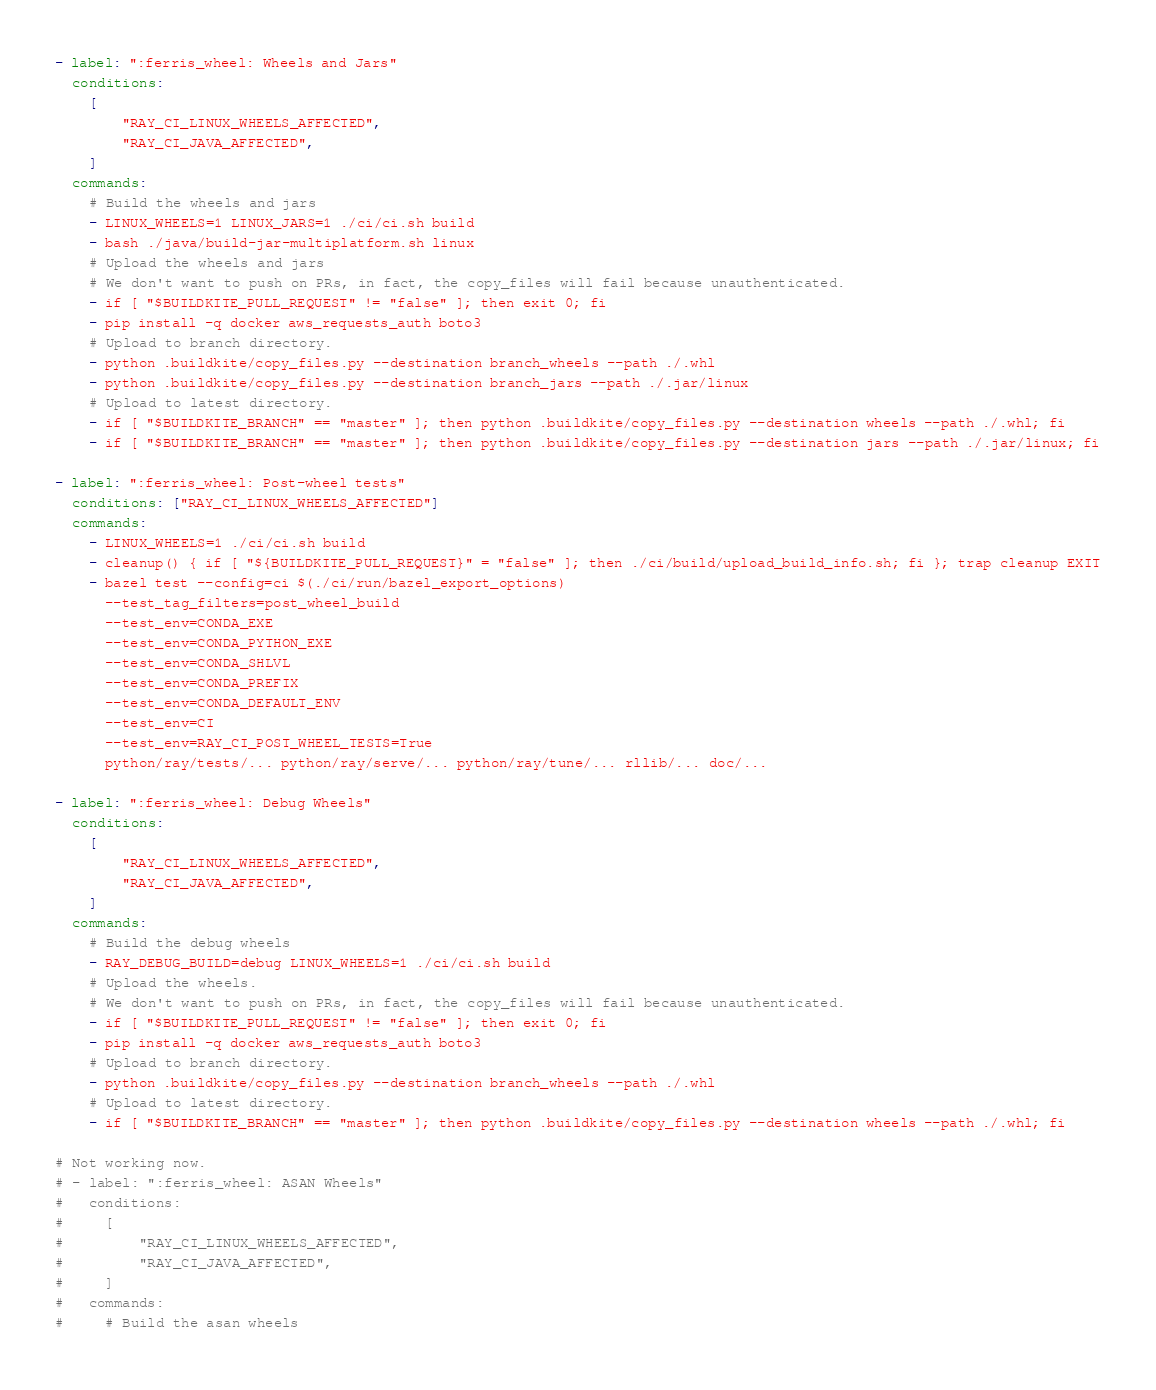<code> <loc_0><loc_0><loc_500><loc_500><_YAML_>- label: ":ferris_wheel: Wheels and Jars"
  conditions:
    [
        "RAY_CI_LINUX_WHEELS_AFFECTED",
        "RAY_CI_JAVA_AFFECTED",
    ]
  commands:
    # Build the wheels and jars
    - LINUX_WHEELS=1 LINUX_JARS=1 ./ci/ci.sh build
    - bash ./java/build-jar-multiplatform.sh linux
    # Upload the wheels and jars
    # We don't want to push on PRs, in fact, the copy_files will fail because unauthenticated.
    - if [ "$BUILDKITE_PULL_REQUEST" != "false" ]; then exit 0; fi
    - pip install -q docker aws_requests_auth boto3
    # Upload to branch directory.
    - python .buildkite/copy_files.py --destination branch_wheels --path ./.whl
    - python .buildkite/copy_files.py --destination branch_jars --path ./.jar/linux
    # Upload to latest directory.
    - if [ "$BUILDKITE_BRANCH" == "master" ]; then python .buildkite/copy_files.py --destination wheels --path ./.whl; fi
    - if [ "$BUILDKITE_BRANCH" == "master" ]; then python .buildkite/copy_files.py --destination jars --path ./.jar/linux; fi

- label: ":ferris_wheel: Post-wheel tests"
  conditions: ["RAY_CI_LINUX_WHEELS_AFFECTED"]
  commands:
    - LINUX_WHEELS=1 ./ci/ci.sh build
    - cleanup() { if [ "${BUILDKITE_PULL_REQUEST}" = "false" ]; then ./ci/build/upload_build_info.sh; fi }; trap cleanup EXIT
    - bazel test --config=ci $(./ci/run/bazel_export_options)
      --test_tag_filters=post_wheel_build
      --test_env=CONDA_EXE
      --test_env=CONDA_PYTHON_EXE
      --test_env=CONDA_SHLVL
      --test_env=CONDA_PREFIX
      --test_env=CONDA_DEFAULT_ENV
      --test_env=CI
      --test_env=RAY_CI_POST_WHEEL_TESTS=True
      python/ray/tests/... python/ray/serve/... python/ray/tune/... rllib/... doc/...

- label: ":ferris_wheel: Debug Wheels"
  conditions:
    [
        "RAY_CI_LINUX_WHEELS_AFFECTED",
        "RAY_CI_JAVA_AFFECTED",
    ]
  commands:
    # Build the debug wheels
    - RAY_DEBUG_BUILD=debug LINUX_WHEELS=1 ./ci/ci.sh build
    # Upload the wheels.
    # We don't want to push on PRs, in fact, the copy_files will fail because unauthenticated.
    - if [ "$BUILDKITE_PULL_REQUEST" != "false" ]; then exit 0; fi
    - pip install -q docker aws_requests_auth boto3
    # Upload to branch directory.
    - python .buildkite/copy_files.py --destination branch_wheels --path ./.whl
    # Upload to latest directory.
    - if [ "$BUILDKITE_BRANCH" == "master" ]; then python .buildkite/copy_files.py --destination wheels --path ./.whl; fi

# Not working now.
# - label: ":ferris_wheel: ASAN Wheels"
#   conditions:
#     [
#         "RAY_CI_LINUX_WHEELS_AFFECTED",
#         "RAY_CI_JAVA_AFFECTED",
#     ]
#   commands:
#     # Build the asan wheels</code> 